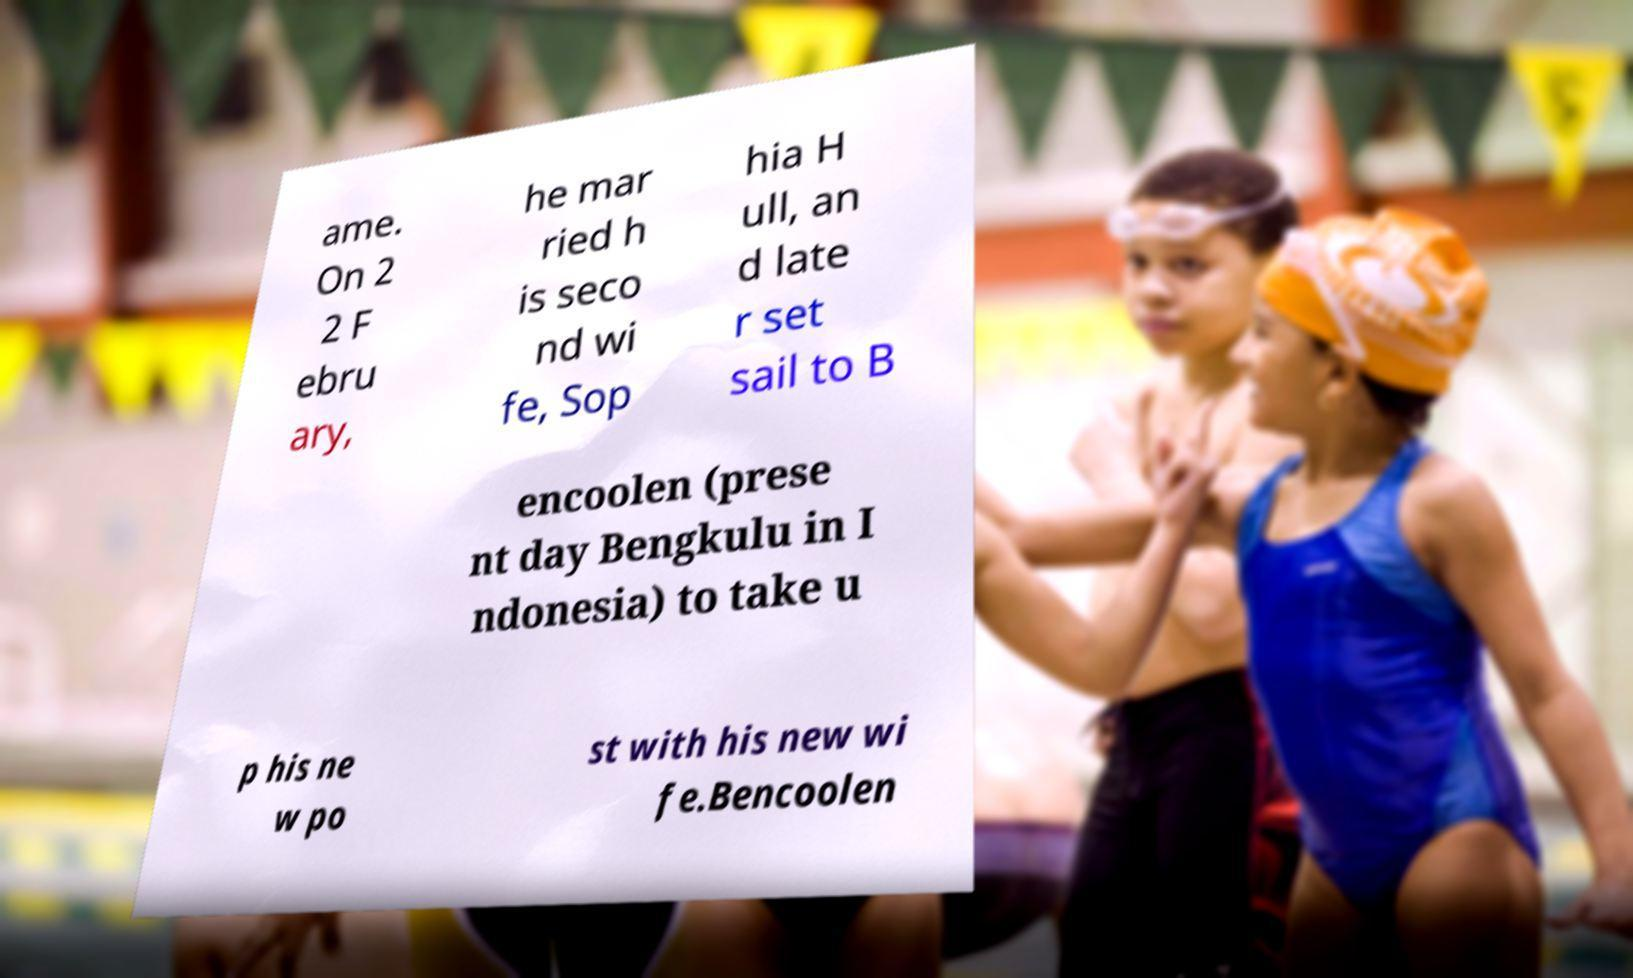Please identify and transcribe the text found in this image. ame. On 2 2 F ebru ary, he mar ried h is seco nd wi fe, Sop hia H ull, an d late r set sail to B encoolen (prese nt day Bengkulu in I ndonesia) to take u p his ne w po st with his new wi fe.Bencoolen 